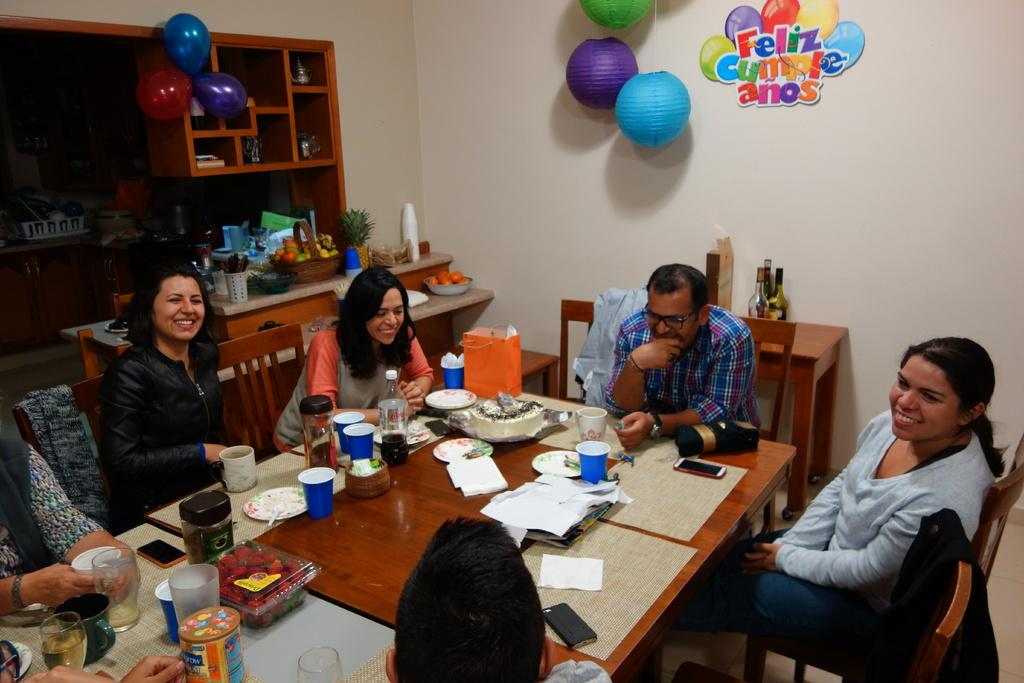How many people are in the image? There is a group of people in the image, but the exact number is not specified. What are the people doing in the image? The people are sitting on chairs in the image. How are the chairs arranged in the image? The chairs are arranged around a dining table in the image. What can be seen behind the people in the image? There is a wall visible behind the people in the image. What type of jellyfish can be seen swimming in the image? There are no jellyfish present in the image; it features a group of people sitting around a dining table. 